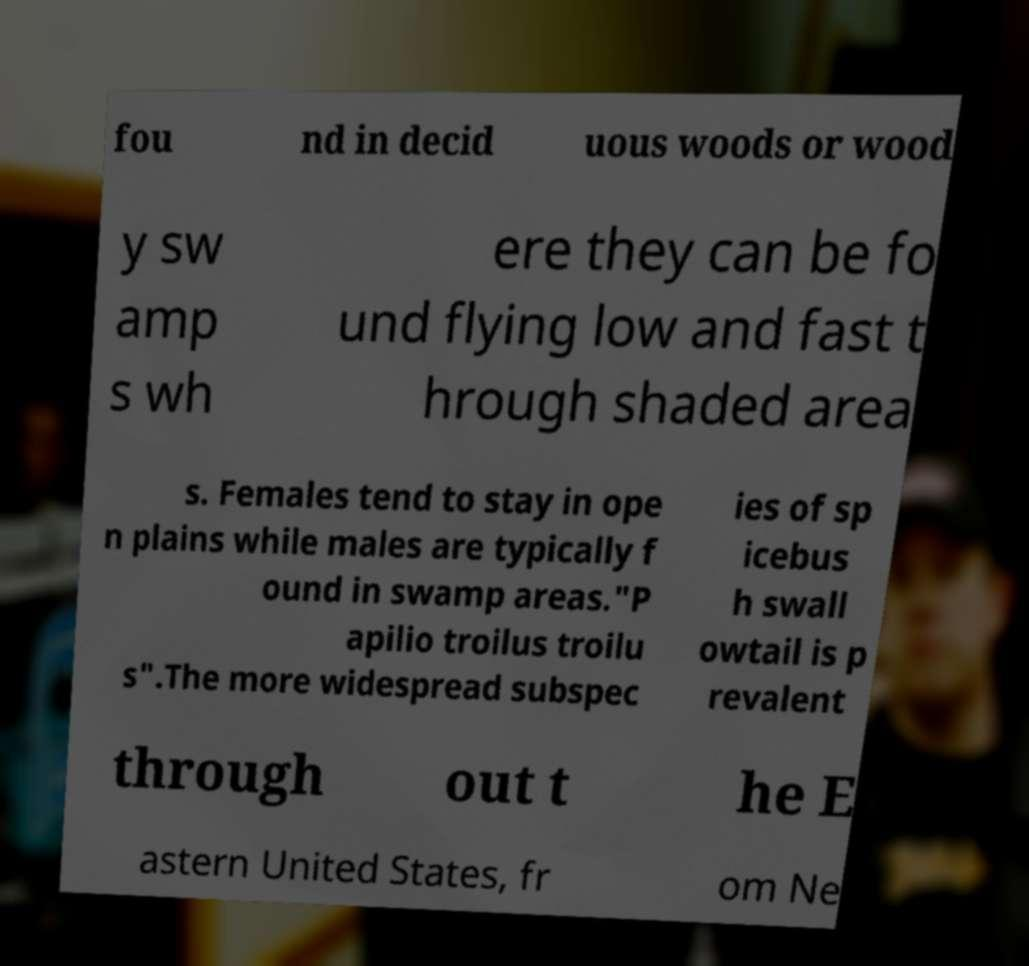Can you accurately transcribe the text from the provided image for me? fou nd in decid uous woods or wood y sw amp s wh ere they can be fo und flying low and fast t hrough shaded area s. Females tend to stay in ope n plains while males are typically f ound in swamp areas."P apilio troilus troilu s".The more widespread subspec ies of sp icebus h swall owtail is p revalent through out t he E astern United States, fr om Ne 